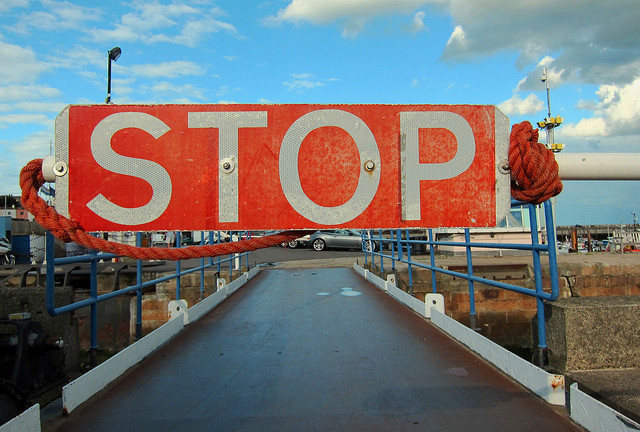How many people are riding the bike farthest to the left? 0 